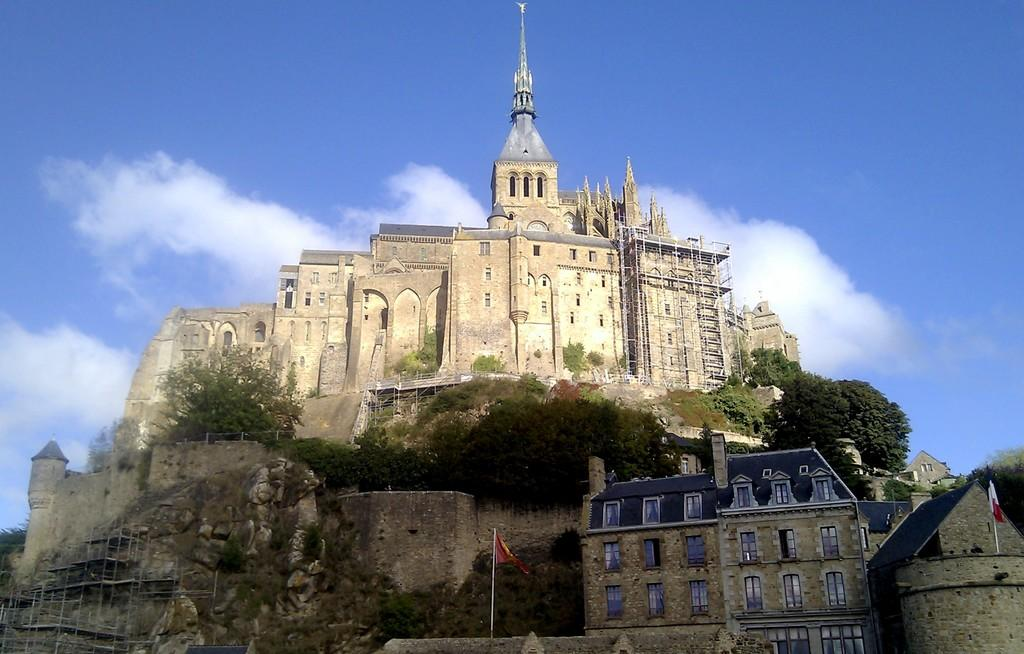What type of structures can be seen in the image? There are buildings in the image. What other natural elements are present in the image? There are trees in the image. Are there any symbols or markers visible in the image? Yes, there are flags in the image. What can be seen in the background of the image? The sky is visible in the background of the image. What is the weather like in the image? The presence of clouds in the sky suggests that it might be partly cloudy. What type of company is represented by the house in the image? There is no house present in the image; it features buildings, trees, flags, and a sky with clouds. How many bits of information can be found in the image? The concept of "bits" is not applicable to the image, as it refers to digital data and the image is a photograph. 